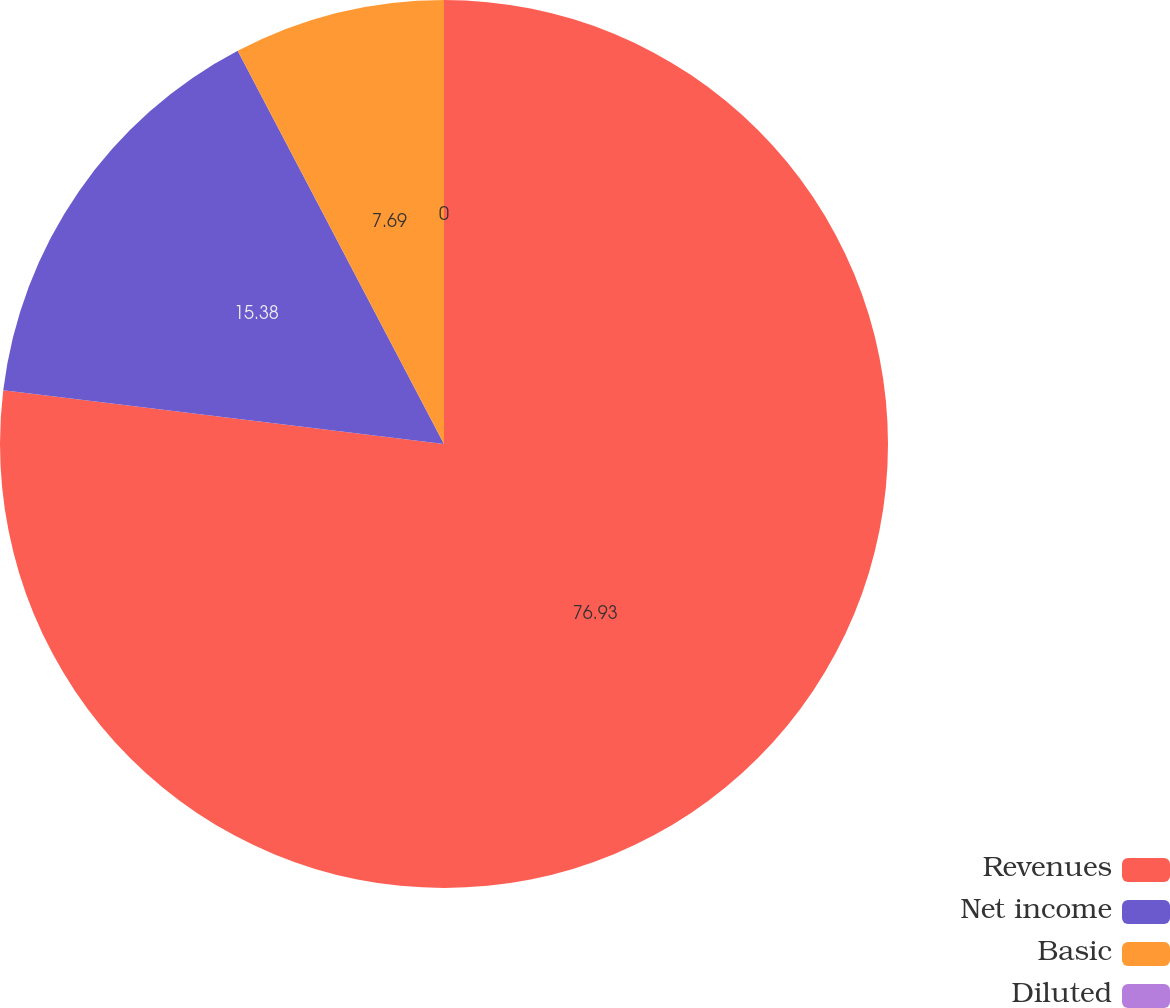Convert chart. <chart><loc_0><loc_0><loc_500><loc_500><pie_chart><fcel>Revenues<fcel>Net income<fcel>Basic<fcel>Diluted<nl><fcel>76.92%<fcel>15.38%<fcel>7.69%<fcel>0.0%<nl></chart> 